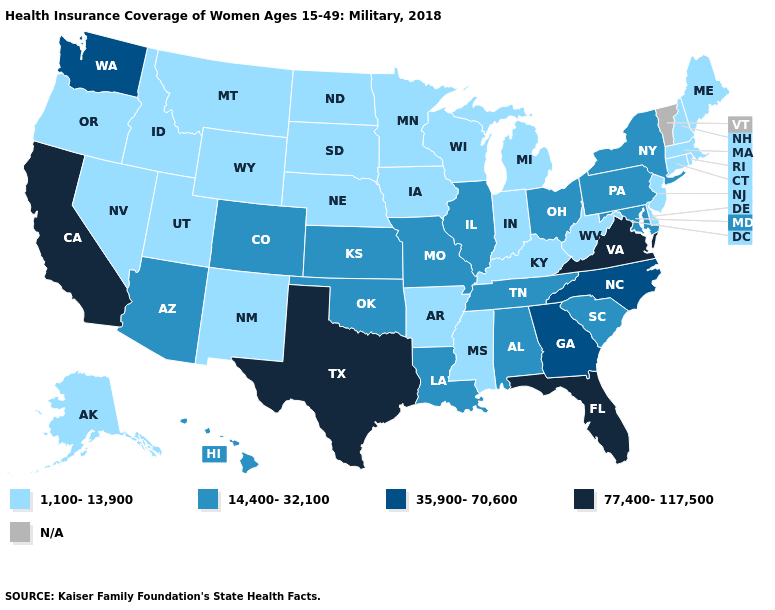What is the value of Louisiana?
Concise answer only. 14,400-32,100. Does the map have missing data?
Write a very short answer. Yes. What is the value of Washington?
Write a very short answer. 35,900-70,600. Is the legend a continuous bar?
Keep it brief. No. Name the states that have a value in the range N/A?
Quick response, please. Vermont. Name the states that have a value in the range 77,400-117,500?
Quick response, please. California, Florida, Texas, Virginia. Name the states that have a value in the range 14,400-32,100?
Be succinct. Alabama, Arizona, Colorado, Hawaii, Illinois, Kansas, Louisiana, Maryland, Missouri, New York, Ohio, Oklahoma, Pennsylvania, South Carolina, Tennessee. Name the states that have a value in the range N/A?
Keep it brief. Vermont. Does the first symbol in the legend represent the smallest category?
Quick response, please. Yes. Does Texas have the highest value in the USA?
Give a very brief answer. Yes. Name the states that have a value in the range 1,100-13,900?
Answer briefly. Alaska, Arkansas, Connecticut, Delaware, Idaho, Indiana, Iowa, Kentucky, Maine, Massachusetts, Michigan, Minnesota, Mississippi, Montana, Nebraska, Nevada, New Hampshire, New Jersey, New Mexico, North Dakota, Oregon, Rhode Island, South Dakota, Utah, West Virginia, Wisconsin, Wyoming. Does the map have missing data?
Give a very brief answer. Yes. What is the value of Connecticut?
Short answer required. 1,100-13,900. What is the value of Maryland?
Quick response, please. 14,400-32,100. What is the lowest value in the MidWest?
Write a very short answer. 1,100-13,900. 